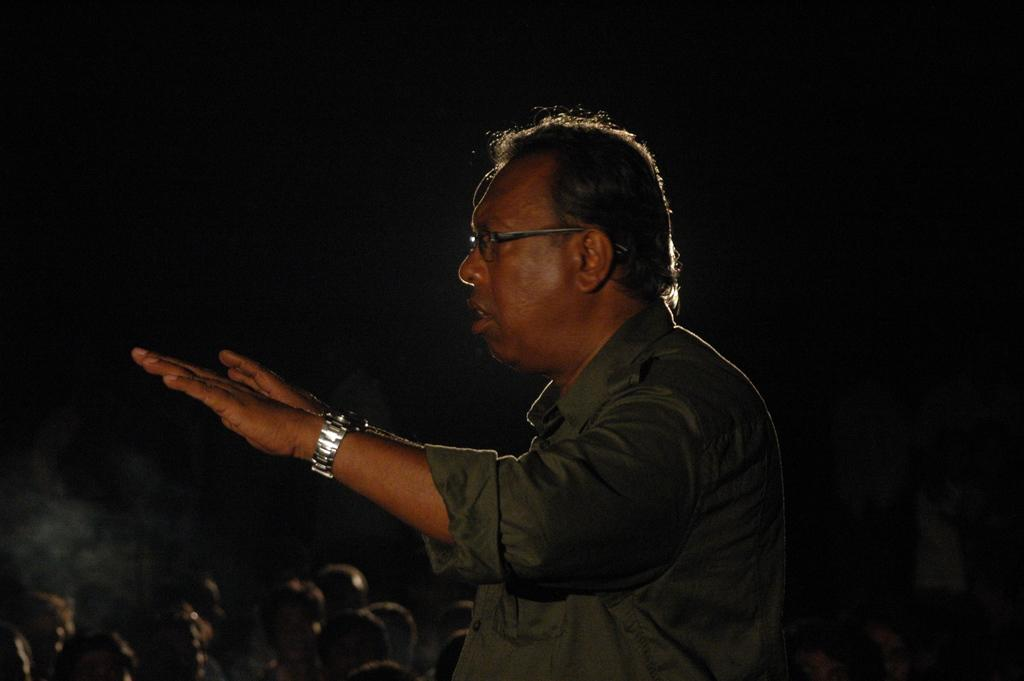What can be seen in the image? There is a person in the image. Can you describe the person's clothing? The person is wearing a black shirt. What accessories is the person wearing? The person is wearing spectacles and a silver-colored watch. What can be seen in the background of the image? There are heads of a few persons in the background. What is the color of the background? The background is black in color. What type of crime is the person committing in the image? There is no indication of any crime being committed in the image. Can you see the person's father in the image? There is no mention of a father or any family members in the image. 